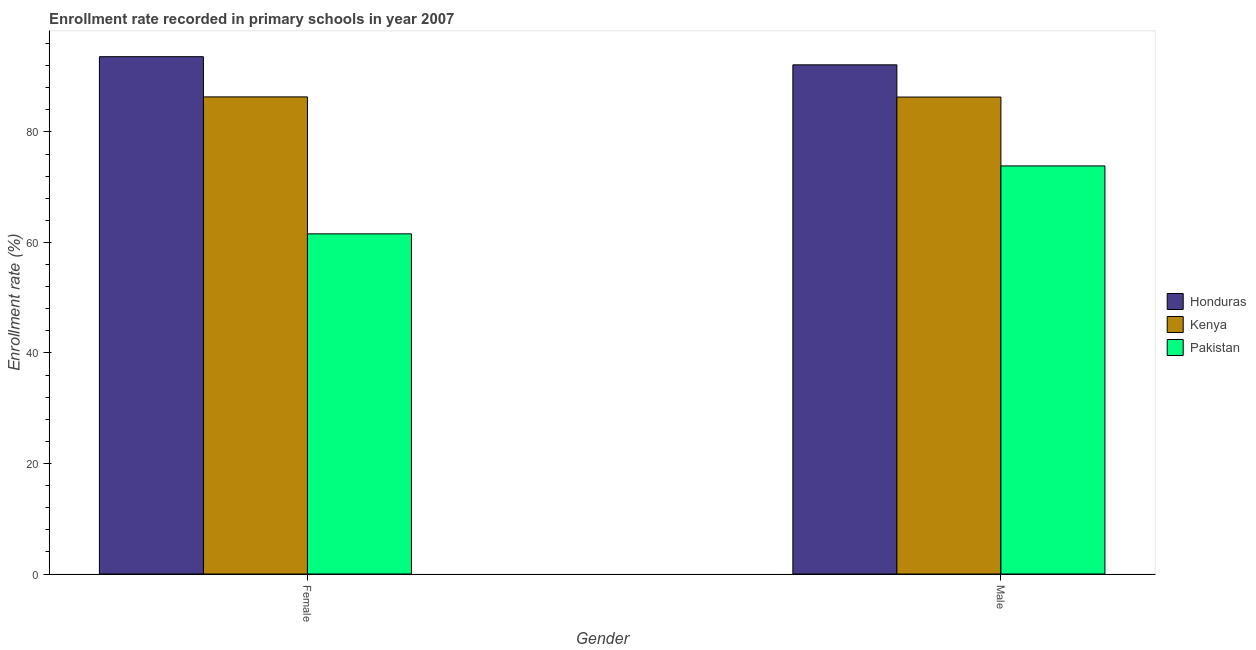Are the number of bars on each tick of the X-axis equal?
Keep it short and to the point. Yes. How many bars are there on the 2nd tick from the left?
Your answer should be very brief. 3. What is the label of the 2nd group of bars from the left?
Provide a succinct answer. Male. What is the enrollment rate of female students in Kenya?
Your answer should be compact. 86.34. Across all countries, what is the maximum enrollment rate of male students?
Offer a terse response. 92.14. Across all countries, what is the minimum enrollment rate of male students?
Your response must be concise. 73.85. In which country was the enrollment rate of male students maximum?
Your answer should be very brief. Honduras. What is the total enrollment rate of male students in the graph?
Your answer should be very brief. 252.3. What is the difference between the enrollment rate of female students in Pakistan and that in Honduras?
Offer a very short reply. -32.06. What is the difference between the enrollment rate of male students in Kenya and the enrollment rate of female students in Pakistan?
Your answer should be very brief. 24.76. What is the average enrollment rate of male students per country?
Give a very brief answer. 84.1. What is the difference between the enrollment rate of female students and enrollment rate of male students in Pakistan?
Your response must be concise. -12.29. What is the ratio of the enrollment rate of female students in Honduras to that in Kenya?
Make the answer very short. 1.08. Is the enrollment rate of female students in Honduras less than that in Pakistan?
Make the answer very short. No. In how many countries, is the enrollment rate of female students greater than the average enrollment rate of female students taken over all countries?
Make the answer very short. 2. What does the 1st bar from the right in Male represents?
Your answer should be very brief. Pakistan. Are all the bars in the graph horizontal?
Offer a very short reply. No. How many countries are there in the graph?
Provide a succinct answer. 3. What is the difference between two consecutive major ticks on the Y-axis?
Offer a very short reply. 20. Does the graph contain any zero values?
Offer a very short reply. No. Does the graph contain grids?
Make the answer very short. No. How many legend labels are there?
Provide a succinct answer. 3. How are the legend labels stacked?
Your answer should be compact. Vertical. What is the title of the graph?
Your response must be concise. Enrollment rate recorded in primary schools in year 2007. Does "Lesotho" appear as one of the legend labels in the graph?
Offer a terse response. No. What is the label or title of the X-axis?
Make the answer very short. Gender. What is the label or title of the Y-axis?
Your response must be concise. Enrollment rate (%). What is the Enrollment rate (%) in Honduras in Female?
Keep it short and to the point. 93.62. What is the Enrollment rate (%) of Kenya in Female?
Your response must be concise. 86.34. What is the Enrollment rate (%) in Pakistan in Female?
Offer a terse response. 61.56. What is the Enrollment rate (%) of Honduras in Male?
Make the answer very short. 92.14. What is the Enrollment rate (%) in Kenya in Male?
Provide a short and direct response. 86.31. What is the Enrollment rate (%) in Pakistan in Male?
Keep it short and to the point. 73.85. Across all Gender, what is the maximum Enrollment rate (%) of Honduras?
Make the answer very short. 93.62. Across all Gender, what is the maximum Enrollment rate (%) in Kenya?
Provide a short and direct response. 86.34. Across all Gender, what is the maximum Enrollment rate (%) in Pakistan?
Your response must be concise. 73.85. Across all Gender, what is the minimum Enrollment rate (%) of Honduras?
Provide a succinct answer. 92.14. Across all Gender, what is the minimum Enrollment rate (%) in Kenya?
Your answer should be very brief. 86.31. Across all Gender, what is the minimum Enrollment rate (%) of Pakistan?
Make the answer very short. 61.56. What is the total Enrollment rate (%) in Honduras in the graph?
Your answer should be very brief. 185.76. What is the total Enrollment rate (%) of Kenya in the graph?
Ensure brevity in your answer.  172.65. What is the total Enrollment rate (%) in Pakistan in the graph?
Your response must be concise. 135.41. What is the difference between the Enrollment rate (%) of Honduras in Female and that in Male?
Give a very brief answer. 1.47. What is the difference between the Enrollment rate (%) of Kenya in Female and that in Male?
Keep it short and to the point. 0.03. What is the difference between the Enrollment rate (%) of Pakistan in Female and that in Male?
Keep it short and to the point. -12.29. What is the difference between the Enrollment rate (%) in Honduras in Female and the Enrollment rate (%) in Kenya in Male?
Ensure brevity in your answer.  7.3. What is the difference between the Enrollment rate (%) of Honduras in Female and the Enrollment rate (%) of Pakistan in Male?
Your response must be concise. 19.76. What is the difference between the Enrollment rate (%) in Kenya in Female and the Enrollment rate (%) in Pakistan in Male?
Keep it short and to the point. 12.49. What is the average Enrollment rate (%) of Honduras per Gender?
Your answer should be very brief. 92.88. What is the average Enrollment rate (%) of Kenya per Gender?
Offer a very short reply. 86.33. What is the average Enrollment rate (%) of Pakistan per Gender?
Keep it short and to the point. 67.7. What is the difference between the Enrollment rate (%) of Honduras and Enrollment rate (%) of Kenya in Female?
Offer a very short reply. 7.28. What is the difference between the Enrollment rate (%) of Honduras and Enrollment rate (%) of Pakistan in Female?
Make the answer very short. 32.06. What is the difference between the Enrollment rate (%) in Kenya and Enrollment rate (%) in Pakistan in Female?
Offer a very short reply. 24.78. What is the difference between the Enrollment rate (%) in Honduras and Enrollment rate (%) in Kenya in Male?
Make the answer very short. 5.83. What is the difference between the Enrollment rate (%) in Honduras and Enrollment rate (%) in Pakistan in Male?
Offer a terse response. 18.29. What is the difference between the Enrollment rate (%) in Kenya and Enrollment rate (%) in Pakistan in Male?
Offer a very short reply. 12.46. What is the ratio of the Enrollment rate (%) of Honduras in Female to that in Male?
Your response must be concise. 1.02. What is the ratio of the Enrollment rate (%) of Kenya in Female to that in Male?
Give a very brief answer. 1. What is the ratio of the Enrollment rate (%) of Pakistan in Female to that in Male?
Offer a very short reply. 0.83. What is the difference between the highest and the second highest Enrollment rate (%) in Honduras?
Offer a very short reply. 1.47. What is the difference between the highest and the second highest Enrollment rate (%) in Kenya?
Your answer should be very brief. 0.03. What is the difference between the highest and the second highest Enrollment rate (%) of Pakistan?
Ensure brevity in your answer.  12.29. What is the difference between the highest and the lowest Enrollment rate (%) in Honduras?
Ensure brevity in your answer.  1.47. What is the difference between the highest and the lowest Enrollment rate (%) of Kenya?
Keep it short and to the point. 0.03. What is the difference between the highest and the lowest Enrollment rate (%) in Pakistan?
Ensure brevity in your answer.  12.29. 